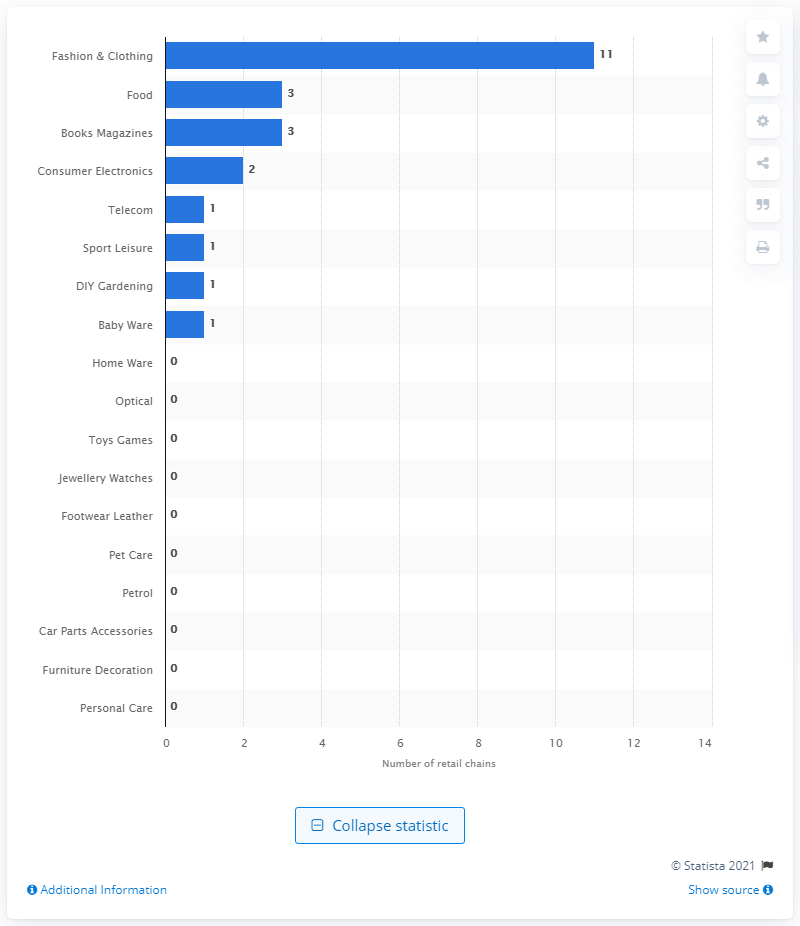Mention a couple of crucial points in this snapshot. In 2020, there were 11 retail chains operating in the fashion and clothing industry in Albania. 